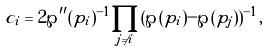Convert formula to latex. <formula><loc_0><loc_0><loc_500><loc_500>c _ { i } = 2 \wp ^ { \prime \prime } ( p _ { i } ) ^ { - 1 } \prod _ { j \ne i } ( \wp ( p _ { i } ) - \wp ( p _ { j } ) ) ^ { - 1 } ,</formula> 